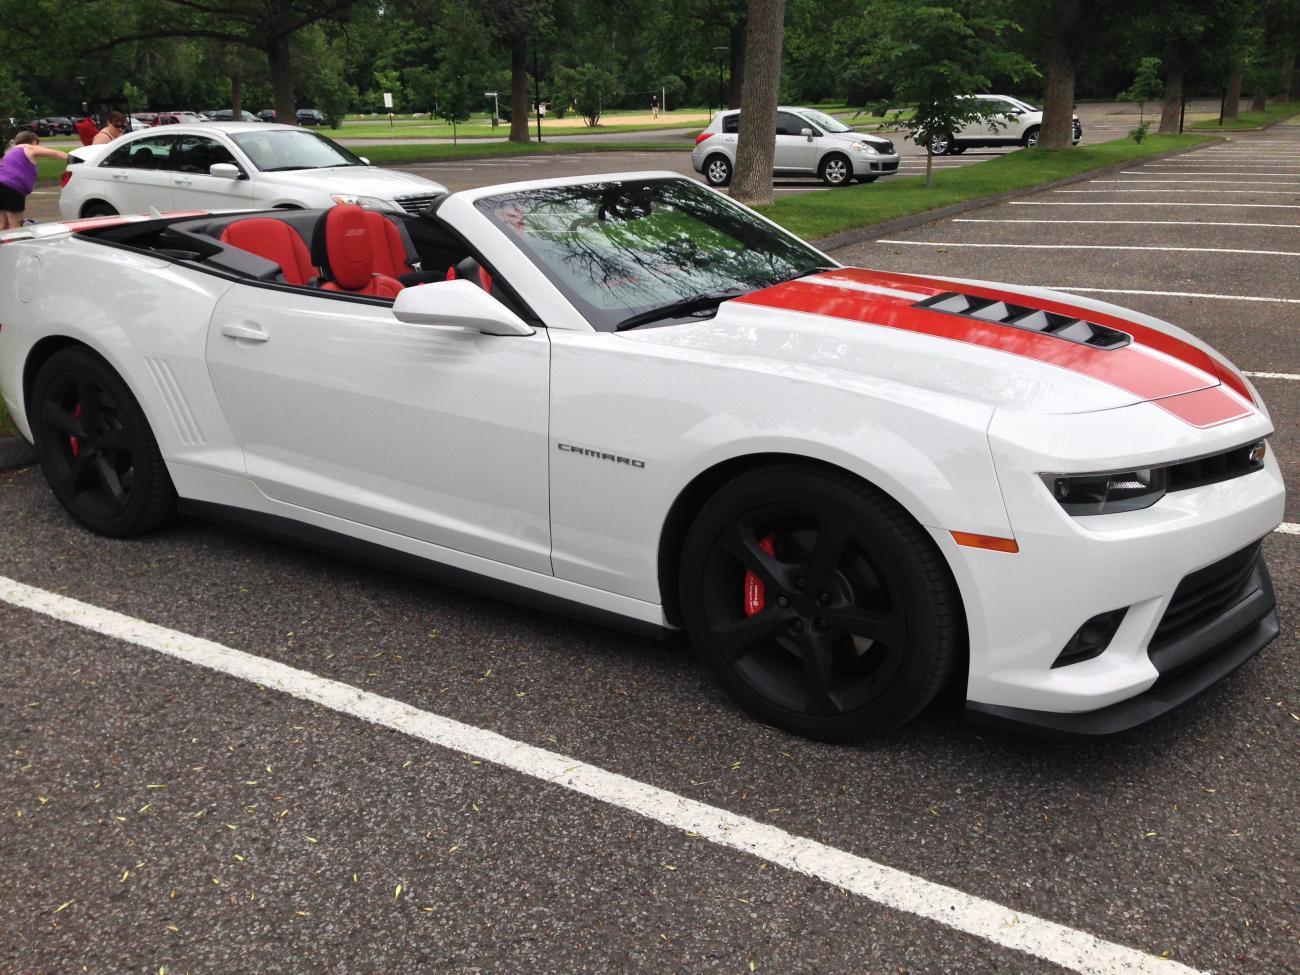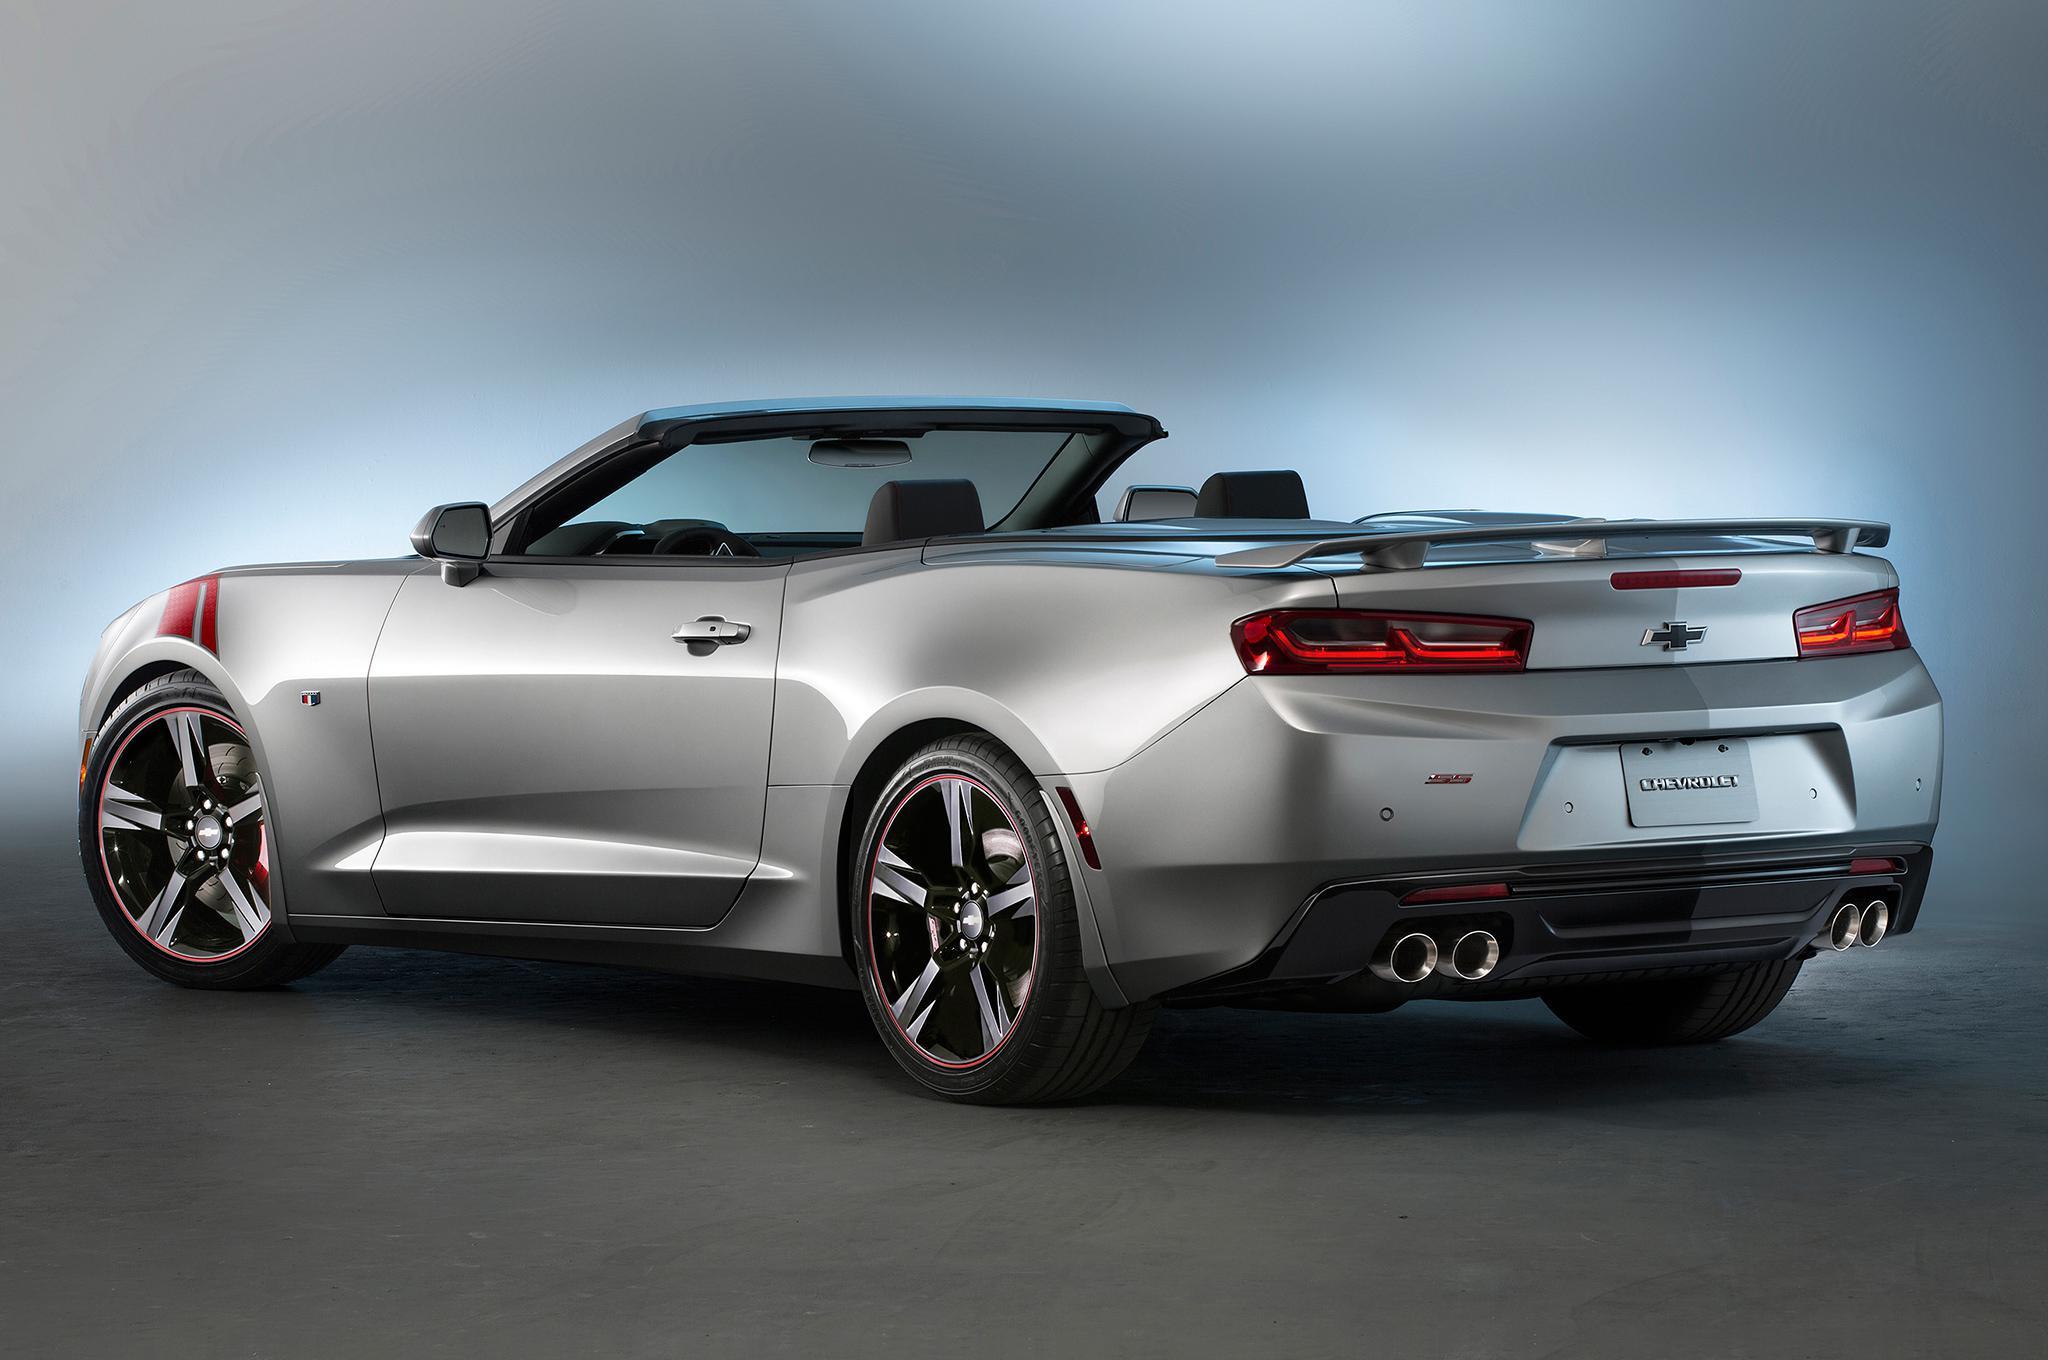The first image is the image on the left, the second image is the image on the right. Evaluate the accuracy of this statement regarding the images: "All cars are photographed with a blurry background as if they are moving.". Is it true? Answer yes or no. No. The first image is the image on the left, the second image is the image on the right. Considering the images on both sides, is "Two convertibles of different makes and colors, with tops down, are being driven on open roads with no other visible traffic." valid? Answer yes or no. No. 